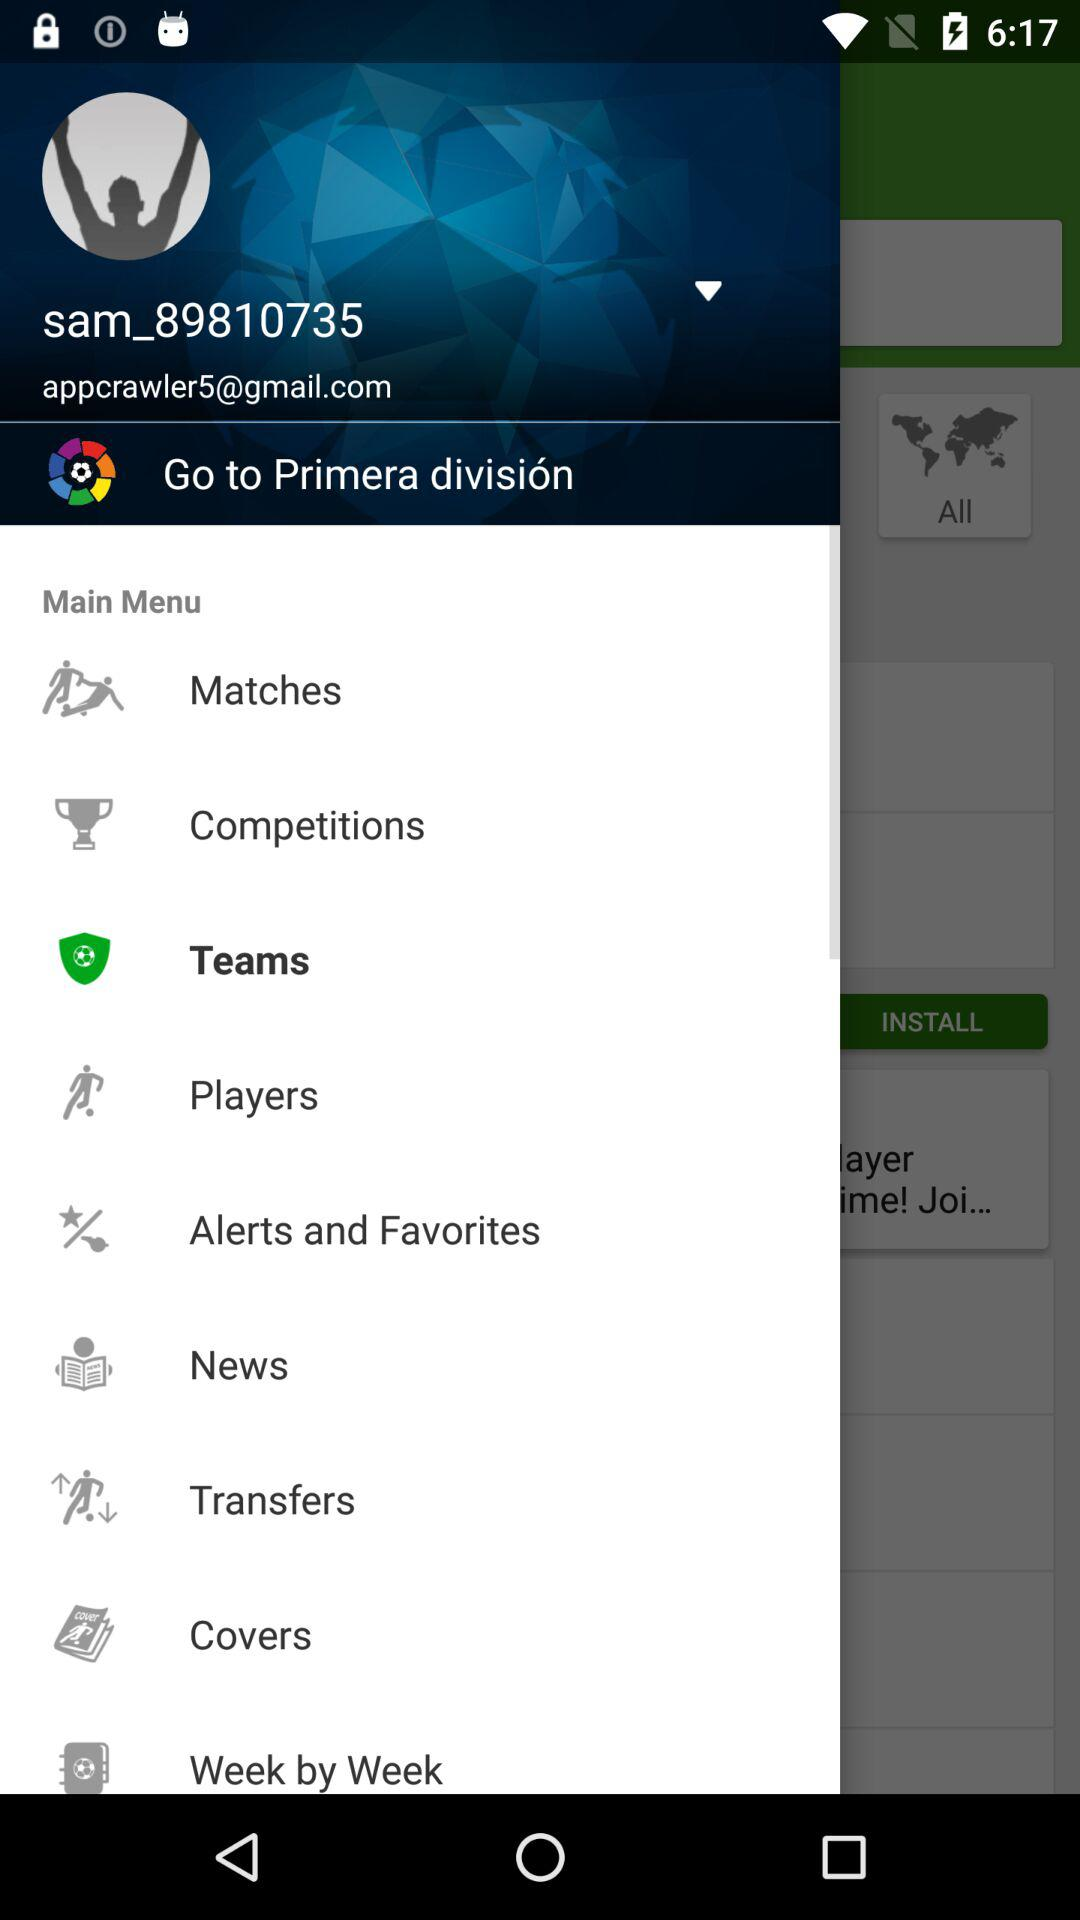What option has been selected? The option that has been selected is "Teams". 